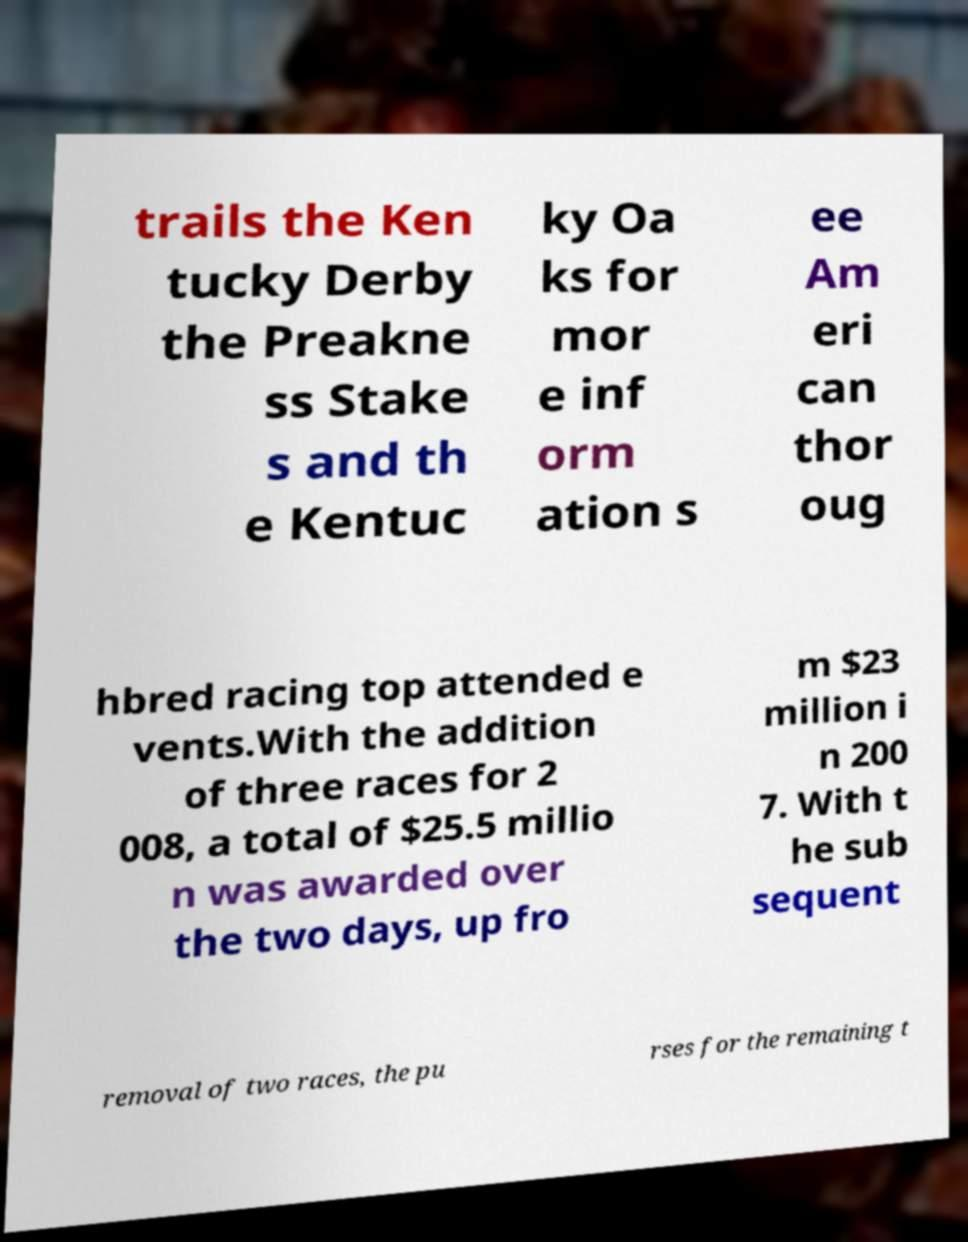I need the written content from this picture converted into text. Can you do that? trails the Ken tucky Derby the Preakne ss Stake s and th e Kentuc ky Oa ks for mor e inf orm ation s ee Am eri can thor oug hbred racing top attended e vents.With the addition of three races for 2 008, a total of $25.5 millio n was awarded over the two days, up fro m $23 million i n 200 7. With t he sub sequent removal of two races, the pu rses for the remaining t 